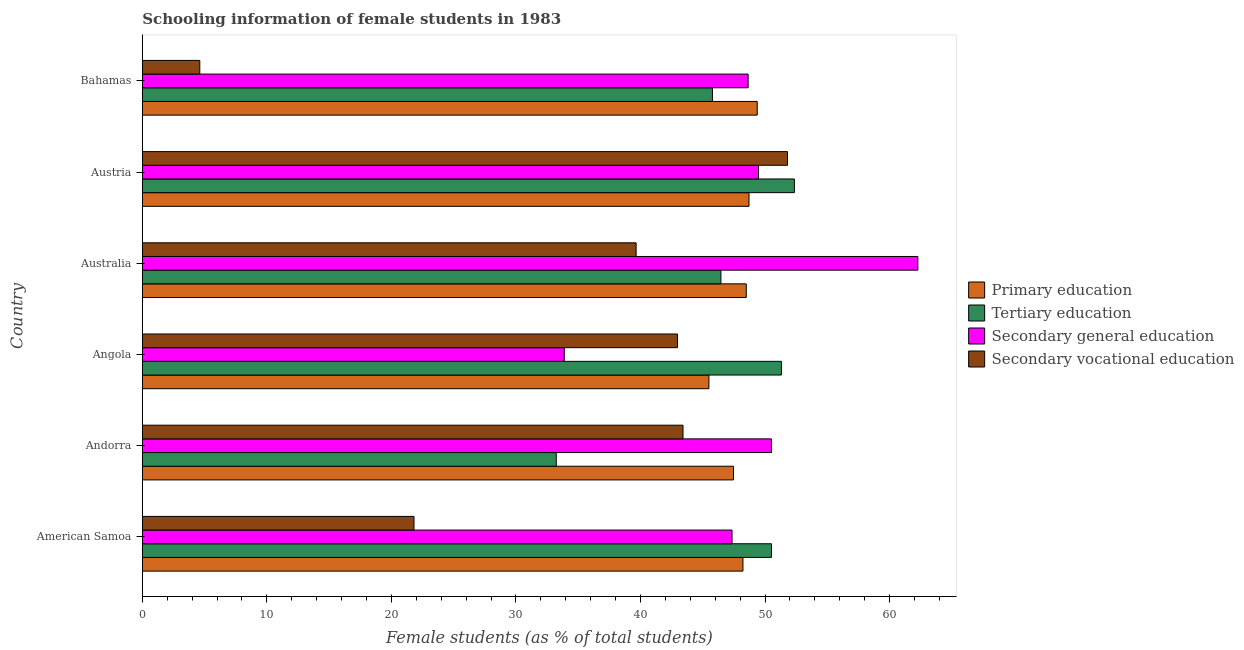How many groups of bars are there?
Give a very brief answer. 6. Are the number of bars on each tick of the Y-axis equal?
Provide a succinct answer. Yes. How many bars are there on the 4th tick from the top?
Keep it short and to the point. 4. What is the label of the 1st group of bars from the top?
Your response must be concise. Bahamas. What is the percentage of female students in tertiary education in American Samoa?
Give a very brief answer. 50.52. Across all countries, what is the maximum percentage of female students in secondary vocational education?
Your response must be concise. 51.8. Across all countries, what is the minimum percentage of female students in primary education?
Offer a terse response. 45.49. In which country was the percentage of female students in secondary education maximum?
Make the answer very short. Australia. In which country was the percentage of female students in secondary education minimum?
Your response must be concise. Angola. What is the total percentage of female students in secondary education in the graph?
Give a very brief answer. 292.13. What is the difference between the percentage of female students in tertiary education in Australia and that in Bahamas?
Offer a terse response. 0.68. What is the difference between the percentage of female students in tertiary education in Angola and the percentage of female students in primary education in Bahamas?
Your answer should be very brief. 1.94. What is the average percentage of female students in tertiary education per country?
Offer a very short reply. 46.61. What is the difference between the percentage of female students in tertiary education and percentage of female students in secondary vocational education in Bahamas?
Your response must be concise. 41.16. Is the percentage of female students in secondary education in Andorra less than that in Bahamas?
Your response must be concise. No. Is the difference between the percentage of female students in secondary vocational education in Angola and Austria greater than the difference between the percentage of female students in tertiary education in Angola and Austria?
Give a very brief answer. No. What is the difference between the highest and the second highest percentage of female students in primary education?
Offer a terse response. 0.66. What is the difference between the highest and the lowest percentage of female students in tertiary education?
Provide a short and direct response. 19.12. In how many countries, is the percentage of female students in primary education greater than the average percentage of female students in primary education taken over all countries?
Keep it short and to the point. 4. Is the sum of the percentage of female students in secondary vocational education in American Samoa and Bahamas greater than the maximum percentage of female students in primary education across all countries?
Give a very brief answer. No. What does the 1st bar from the top in Bahamas represents?
Give a very brief answer. Secondary vocational education. What does the 3rd bar from the bottom in American Samoa represents?
Your response must be concise. Secondary general education. Is it the case that in every country, the sum of the percentage of female students in primary education and percentage of female students in tertiary education is greater than the percentage of female students in secondary education?
Give a very brief answer. Yes. Are all the bars in the graph horizontal?
Your answer should be compact. Yes. What is the difference between two consecutive major ticks on the X-axis?
Your answer should be compact. 10. Are the values on the major ticks of X-axis written in scientific E-notation?
Offer a terse response. No. Does the graph contain grids?
Provide a short and direct response. No. How many legend labels are there?
Give a very brief answer. 4. What is the title of the graph?
Your answer should be compact. Schooling information of female students in 1983. What is the label or title of the X-axis?
Offer a very short reply. Female students (as % of total students). What is the label or title of the Y-axis?
Provide a short and direct response. Country. What is the Female students (as % of total students) in Primary education in American Samoa?
Provide a short and direct response. 48.22. What is the Female students (as % of total students) of Tertiary education in American Samoa?
Your response must be concise. 50.52. What is the Female students (as % of total students) in Secondary general education in American Samoa?
Give a very brief answer. 47.35. What is the Female students (as % of total students) in Secondary vocational education in American Samoa?
Offer a very short reply. 21.81. What is the Female students (as % of total students) of Primary education in Andorra?
Provide a short and direct response. 47.47. What is the Female students (as % of total students) of Tertiary education in Andorra?
Provide a short and direct response. 33.23. What is the Female students (as % of total students) in Secondary general education in Andorra?
Provide a succinct answer. 50.52. What is the Female students (as % of total students) of Secondary vocational education in Andorra?
Keep it short and to the point. 43.41. What is the Female students (as % of total students) in Primary education in Angola?
Provide a short and direct response. 45.49. What is the Female students (as % of total students) of Tertiary education in Angola?
Your answer should be compact. 51.32. What is the Female students (as % of total students) in Secondary general education in Angola?
Your response must be concise. 33.88. What is the Female students (as % of total students) of Secondary vocational education in Angola?
Your response must be concise. 42.97. What is the Female students (as % of total students) of Primary education in Australia?
Provide a succinct answer. 48.49. What is the Female students (as % of total students) of Tertiary education in Australia?
Your answer should be compact. 46.46. What is the Female students (as % of total students) of Secondary general education in Australia?
Provide a short and direct response. 62.27. What is the Female students (as % of total students) of Secondary vocational education in Australia?
Make the answer very short. 39.65. What is the Female students (as % of total students) of Primary education in Austria?
Your response must be concise. 48.71. What is the Female students (as % of total students) in Tertiary education in Austria?
Give a very brief answer. 52.36. What is the Female students (as % of total students) in Secondary general education in Austria?
Provide a short and direct response. 49.48. What is the Female students (as % of total students) of Secondary vocational education in Austria?
Your answer should be very brief. 51.8. What is the Female students (as % of total students) of Primary education in Bahamas?
Make the answer very short. 49.37. What is the Female students (as % of total students) of Tertiary education in Bahamas?
Make the answer very short. 45.78. What is the Female students (as % of total students) in Secondary general education in Bahamas?
Ensure brevity in your answer.  48.64. What is the Female students (as % of total students) of Secondary vocational education in Bahamas?
Make the answer very short. 4.61. Across all countries, what is the maximum Female students (as % of total students) in Primary education?
Your answer should be very brief. 49.37. Across all countries, what is the maximum Female students (as % of total students) of Tertiary education?
Provide a succinct answer. 52.36. Across all countries, what is the maximum Female students (as % of total students) of Secondary general education?
Your response must be concise. 62.27. Across all countries, what is the maximum Female students (as % of total students) of Secondary vocational education?
Offer a very short reply. 51.8. Across all countries, what is the minimum Female students (as % of total students) in Primary education?
Your answer should be compact. 45.49. Across all countries, what is the minimum Female students (as % of total students) in Tertiary education?
Make the answer very short. 33.23. Across all countries, what is the minimum Female students (as % of total students) of Secondary general education?
Your answer should be compact. 33.88. Across all countries, what is the minimum Female students (as % of total students) in Secondary vocational education?
Your answer should be very brief. 4.61. What is the total Female students (as % of total students) of Primary education in the graph?
Your response must be concise. 287.76. What is the total Female students (as % of total students) of Tertiary education in the graph?
Keep it short and to the point. 279.66. What is the total Female students (as % of total students) in Secondary general education in the graph?
Make the answer very short. 292.13. What is the total Female students (as % of total students) in Secondary vocational education in the graph?
Ensure brevity in your answer.  204.26. What is the difference between the Female students (as % of total students) of Primary education in American Samoa and that in Andorra?
Your answer should be very brief. 0.76. What is the difference between the Female students (as % of total students) of Tertiary education in American Samoa and that in Andorra?
Your answer should be compact. 17.28. What is the difference between the Female students (as % of total students) in Secondary general education in American Samoa and that in Andorra?
Keep it short and to the point. -3.17. What is the difference between the Female students (as % of total students) of Secondary vocational education in American Samoa and that in Andorra?
Give a very brief answer. -21.6. What is the difference between the Female students (as % of total students) in Primary education in American Samoa and that in Angola?
Offer a very short reply. 2.73. What is the difference between the Female students (as % of total students) in Tertiary education in American Samoa and that in Angola?
Give a very brief answer. -0.8. What is the difference between the Female students (as % of total students) of Secondary general education in American Samoa and that in Angola?
Make the answer very short. 13.47. What is the difference between the Female students (as % of total students) of Secondary vocational education in American Samoa and that in Angola?
Your answer should be very brief. -21.16. What is the difference between the Female students (as % of total students) in Primary education in American Samoa and that in Australia?
Your answer should be very brief. -0.27. What is the difference between the Female students (as % of total students) of Tertiary education in American Samoa and that in Australia?
Offer a very short reply. 4.06. What is the difference between the Female students (as % of total students) in Secondary general education in American Samoa and that in Australia?
Your response must be concise. -14.92. What is the difference between the Female students (as % of total students) of Secondary vocational education in American Samoa and that in Australia?
Offer a terse response. -17.83. What is the difference between the Female students (as % of total students) in Primary education in American Samoa and that in Austria?
Offer a terse response. -0.49. What is the difference between the Female students (as % of total students) of Tertiary education in American Samoa and that in Austria?
Give a very brief answer. -1.84. What is the difference between the Female students (as % of total students) of Secondary general education in American Samoa and that in Austria?
Give a very brief answer. -2.13. What is the difference between the Female students (as % of total students) in Secondary vocational education in American Samoa and that in Austria?
Make the answer very short. -29.99. What is the difference between the Female students (as % of total students) of Primary education in American Samoa and that in Bahamas?
Your response must be concise. -1.15. What is the difference between the Female students (as % of total students) of Tertiary education in American Samoa and that in Bahamas?
Your response must be concise. 4.74. What is the difference between the Female students (as % of total students) in Secondary general education in American Samoa and that in Bahamas?
Provide a succinct answer. -1.29. What is the difference between the Female students (as % of total students) in Secondary vocational education in American Samoa and that in Bahamas?
Provide a succinct answer. 17.2. What is the difference between the Female students (as % of total students) in Primary education in Andorra and that in Angola?
Give a very brief answer. 1.97. What is the difference between the Female students (as % of total students) in Tertiary education in Andorra and that in Angola?
Provide a short and direct response. -18.08. What is the difference between the Female students (as % of total students) in Secondary general education in Andorra and that in Angola?
Provide a succinct answer. 16.64. What is the difference between the Female students (as % of total students) in Secondary vocational education in Andorra and that in Angola?
Offer a terse response. 0.44. What is the difference between the Female students (as % of total students) of Primary education in Andorra and that in Australia?
Provide a short and direct response. -1.03. What is the difference between the Female students (as % of total students) of Tertiary education in Andorra and that in Australia?
Offer a very short reply. -13.22. What is the difference between the Female students (as % of total students) in Secondary general education in Andorra and that in Australia?
Provide a short and direct response. -11.75. What is the difference between the Female students (as % of total students) in Secondary vocational education in Andorra and that in Australia?
Make the answer very short. 3.77. What is the difference between the Female students (as % of total students) of Primary education in Andorra and that in Austria?
Provide a short and direct response. -1.25. What is the difference between the Female students (as % of total students) of Tertiary education in Andorra and that in Austria?
Give a very brief answer. -19.12. What is the difference between the Female students (as % of total students) in Secondary vocational education in Andorra and that in Austria?
Make the answer very short. -8.39. What is the difference between the Female students (as % of total students) in Primary education in Andorra and that in Bahamas?
Ensure brevity in your answer.  -1.91. What is the difference between the Female students (as % of total students) of Tertiary education in Andorra and that in Bahamas?
Ensure brevity in your answer.  -12.54. What is the difference between the Female students (as % of total students) of Secondary general education in Andorra and that in Bahamas?
Offer a very short reply. 1.87. What is the difference between the Female students (as % of total students) of Secondary vocational education in Andorra and that in Bahamas?
Your response must be concise. 38.8. What is the difference between the Female students (as % of total students) in Primary education in Angola and that in Australia?
Your response must be concise. -3. What is the difference between the Female students (as % of total students) of Tertiary education in Angola and that in Australia?
Your answer should be compact. 4.86. What is the difference between the Female students (as % of total students) of Secondary general education in Angola and that in Australia?
Your answer should be compact. -28.39. What is the difference between the Female students (as % of total students) in Secondary vocational education in Angola and that in Australia?
Offer a terse response. 3.32. What is the difference between the Female students (as % of total students) of Primary education in Angola and that in Austria?
Your answer should be very brief. -3.22. What is the difference between the Female students (as % of total students) of Tertiary education in Angola and that in Austria?
Your answer should be very brief. -1.04. What is the difference between the Female students (as % of total students) in Secondary general education in Angola and that in Austria?
Provide a succinct answer. -15.6. What is the difference between the Female students (as % of total students) in Secondary vocational education in Angola and that in Austria?
Make the answer very short. -8.83. What is the difference between the Female students (as % of total students) of Primary education in Angola and that in Bahamas?
Provide a short and direct response. -3.88. What is the difference between the Female students (as % of total students) of Tertiary education in Angola and that in Bahamas?
Your answer should be compact. 5.54. What is the difference between the Female students (as % of total students) in Secondary general education in Angola and that in Bahamas?
Your answer should be very brief. -14.76. What is the difference between the Female students (as % of total students) of Secondary vocational education in Angola and that in Bahamas?
Ensure brevity in your answer.  38.36. What is the difference between the Female students (as % of total students) in Primary education in Australia and that in Austria?
Offer a terse response. -0.22. What is the difference between the Female students (as % of total students) of Tertiary education in Australia and that in Austria?
Offer a terse response. -5.9. What is the difference between the Female students (as % of total students) of Secondary general education in Australia and that in Austria?
Give a very brief answer. 12.79. What is the difference between the Female students (as % of total students) of Secondary vocational education in Australia and that in Austria?
Give a very brief answer. -12.15. What is the difference between the Female students (as % of total students) of Primary education in Australia and that in Bahamas?
Give a very brief answer. -0.88. What is the difference between the Female students (as % of total students) in Tertiary education in Australia and that in Bahamas?
Your response must be concise. 0.68. What is the difference between the Female students (as % of total students) in Secondary general education in Australia and that in Bahamas?
Your answer should be very brief. 13.63. What is the difference between the Female students (as % of total students) of Secondary vocational education in Australia and that in Bahamas?
Make the answer very short. 35.03. What is the difference between the Female students (as % of total students) of Primary education in Austria and that in Bahamas?
Your response must be concise. -0.66. What is the difference between the Female students (as % of total students) in Tertiary education in Austria and that in Bahamas?
Your answer should be very brief. 6.58. What is the difference between the Female students (as % of total students) of Secondary general education in Austria and that in Bahamas?
Give a very brief answer. 0.83. What is the difference between the Female students (as % of total students) of Secondary vocational education in Austria and that in Bahamas?
Keep it short and to the point. 47.19. What is the difference between the Female students (as % of total students) in Primary education in American Samoa and the Female students (as % of total students) in Tertiary education in Andorra?
Offer a terse response. 14.99. What is the difference between the Female students (as % of total students) of Primary education in American Samoa and the Female students (as % of total students) of Secondary general education in Andorra?
Ensure brevity in your answer.  -2.29. What is the difference between the Female students (as % of total students) of Primary education in American Samoa and the Female students (as % of total students) of Secondary vocational education in Andorra?
Your response must be concise. 4.81. What is the difference between the Female students (as % of total students) in Tertiary education in American Samoa and the Female students (as % of total students) in Secondary general education in Andorra?
Provide a short and direct response. 0. What is the difference between the Female students (as % of total students) of Tertiary education in American Samoa and the Female students (as % of total students) of Secondary vocational education in Andorra?
Keep it short and to the point. 7.1. What is the difference between the Female students (as % of total students) in Secondary general education in American Samoa and the Female students (as % of total students) in Secondary vocational education in Andorra?
Make the answer very short. 3.94. What is the difference between the Female students (as % of total students) of Primary education in American Samoa and the Female students (as % of total students) of Tertiary education in Angola?
Provide a short and direct response. -3.09. What is the difference between the Female students (as % of total students) of Primary education in American Samoa and the Female students (as % of total students) of Secondary general education in Angola?
Offer a very short reply. 14.34. What is the difference between the Female students (as % of total students) in Primary education in American Samoa and the Female students (as % of total students) in Secondary vocational education in Angola?
Your answer should be very brief. 5.25. What is the difference between the Female students (as % of total students) of Tertiary education in American Samoa and the Female students (as % of total students) of Secondary general education in Angola?
Offer a very short reply. 16.64. What is the difference between the Female students (as % of total students) of Tertiary education in American Samoa and the Female students (as % of total students) of Secondary vocational education in Angola?
Make the answer very short. 7.55. What is the difference between the Female students (as % of total students) of Secondary general education in American Samoa and the Female students (as % of total students) of Secondary vocational education in Angola?
Keep it short and to the point. 4.38. What is the difference between the Female students (as % of total students) in Primary education in American Samoa and the Female students (as % of total students) in Tertiary education in Australia?
Offer a very short reply. 1.77. What is the difference between the Female students (as % of total students) in Primary education in American Samoa and the Female students (as % of total students) in Secondary general education in Australia?
Offer a terse response. -14.05. What is the difference between the Female students (as % of total students) of Primary education in American Samoa and the Female students (as % of total students) of Secondary vocational education in Australia?
Keep it short and to the point. 8.58. What is the difference between the Female students (as % of total students) in Tertiary education in American Samoa and the Female students (as % of total students) in Secondary general education in Australia?
Ensure brevity in your answer.  -11.75. What is the difference between the Female students (as % of total students) in Tertiary education in American Samoa and the Female students (as % of total students) in Secondary vocational education in Australia?
Your response must be concise. 10.87. What is the difference between the Female students (as % of total students) of Secondary general education in American Samoa and the Female students (as % of total students) of Secondary vocational education in Australia?
Your answer should be very brief. 7.7. What is the difference between the Female students (as % of total students) in Primary education in American Samoa and the Female students (as % of total students) in Tertiary education in Austria?
Ensure brevity in your answer.  -4.13. What is the difference between the Female students (as % of total students) in Primary education in American Samoa and the Female students (as % of total students) in Secondary general education in Austria?
Keep it short and to the point. -1.25. What is the difference between the Female students (as % of total students) of Primary education in American Samoa and the Female students (as % of total students) of Secondary vocational education in Austria?
Provide a succinct answer. -3.58. What is the difference between the Female students (as % of total students) in Tertiary education in American Samoa and the Female students (as % of total students) in Secondary general education in Austria?
Provide a succinct answer. 1.04. What is the difference between the Female students (as % of total students) in Tertiary education in American Samoa and the Female students (as % of total students) in Secondary vocational education in Austria?
Your answer should be very brief. -1.29. What is the difference between the Female students (as % of total students) in Secondary general education in American Samoa and the Female students (as % of total students) in Secondary vocational education in Austria?
Your answer should be compact. -4.45. What is the difference between the Female students (as % of total students) in Primary education in American Samoa and the Female students (as % of total students) in Tertiary education in Bahamas?
Ensure brevity in your answer.  2.45. What is the difference between the Female students (as % of total students) of Primary education in American Samoa and the Female students (as % of total students) of Secondary general education in Bahamas?
Offer a terse response. -0.42. What is the difference between the Female students (as % of total students) in Primary education in American Samoa and the Female students (as % of total students) in Secondary vocational education in Bahamas?
Provide a short and direct response. 43.61. What is the difference between the Female students (as % of total students) in Tertiary education in American Samoa and the Female students (as % of total students) in Secondary general education in Bahamas?
Provide a succinct answer. 1.87. What is the difference between the Female students (as % of total students) of Tertiary education in American Samoa and the Female students (as % of total students) of Secondary vocational education in Bahamas?
Give a very brief answer. 45.9. What is the difference between the Female students (as % of total students) in Secondary general education in American Samoa and the Female students (as % of total students) in Secondary vocational education in Bahamas?
Your answer should be compact. 42.74. What is the difference between the Female students (as % of total students) of Primary education in Andorra and the Female students (as % of total students) of Tertiary education in Angola?
Your answer should be very brief. -3.85. What is the difference between the Female students (as % of total students) in Primary education in Andorra and the Female students (as % of total students) in Secondary general education in Angola?
Provide a succinct answer. 13.59. What is the difference between the Female students (as % of total students) of Primary education in Andorra and the Female students (as % of total students) of Secondary vocational education in Angola?
Provide a short and direct response. 4.5. What is the difference between the Female students (as % of total students) in Tertiary education in Andorra and the Female students (as % of total students) in Secondary general education in Angola?
Give a very brief answer. -0.65. What is the difference between the Female students (as % of total students) of Tertiary education in Andorra and the Female students (as % of total students) of Secondary vocational education in Angola?
Ensure brevity in your answer.  -9.74. What is the difference between the Female students (as % of total students) of Secondary general education in Andorra and the Female students (as % of total students) of Secondary vocational education in Angola?
Make the answer very short. 7.55. What is the difference between the Female students (as % of total students) in Primary education in Andorra and the Female students (as % of total students) in Tertiary education in Australia?
Provide a short and direct response. 1.01. What is the difference between the Female students (as % of total students) of Primary education in Andorra and the Female students (as % of total students) of Secondary general education in Australia?
Provide a succinct answer. -14.8. What is the difference between the Female students (as % of total students) in Primary education in Andorra and the Female students (as % of total students) in Secondary vocational education in Australia?
Ensure brevity in your answer.  7.82. What is the difference between the Female students (as % of total students) of Tertiary education in Andorra and the Female students (as % of total students) of Secondary general education in Australia?
Ensure brevity in your answer.  -29.04. What is the difference between the Female students (as % of total students) in Tertiary education in Andorra and the Female students (as % of total students) in Secondary vocational education in Australia?
Keep it short and to the point. -6.41. What is the difference between the Female students (as % of total students) of Secondary general education in Andorra and the Female students (as % of total students) of Secondary vocational education in Australia?
Your answer should be compact. 10.87. What is the difference between the Female students (as % of total students) in Primary education in Andorra and the Female students (as % of total students) in Tertiary education in Austria?
Provide a short and direct response. -4.89. What is the difference between the Female students (as % of total students) of Primary education in Andorra and the Female students (as % of total students) of Secondary general education in Austria?
Make the answer very short. -2.01. What is the difference between the Female students (as % of total students) of Primary education in Andorra and the Female students (as % of total students) of Secondary vocational education in Austria?
Ensure brevity in your answer.  -4.34. What is the difference between the Female students (as % of total students) of Tertiary education in Andorra and the Female students (as % of total students) of Secondary general education in Austria?
Your answer should be very brief. -16.24. What is the difference between the Female students (as % of total students) of Tertiary education in Andorra and the Female students (as % of total students) of Secondary vocational education in Austria?
Provide a succinct answer. -18.57. What is the difference between the Female students (as % of total students) in Secondary general education in Andorra and the Female students (as % of total students) in Secondary vocational education in Austria?
Provide a short and direct response. -1.29. What is the difference between the Female students (as % of total students) of Primary education in Andorra and the Female students (as % of total students) of Tertiary education in Bahamas?
Offer a very short reply. 1.69. What is the difference between the Female students (as % of total students) in Primary education in Andorra and the Female students (as % of total students) in Secondary general education in Bahamas?
Keep it short and to the point. -1.18. What is the difference between the Female students (as % of total students) of Primary education in Andorra and the Female students (as % of total students) of Secondary vocational education in Bahamas?
Provide a short and direct response. 42.85. What is the difference between the Female students (as % of total students) of Tertiary education in Andorra and the Female students (as % of total students) of Secondary general education in Bahamas?
Provide a succinct answer. -15.41. What is the difference between the Female students (as % of total students) of Tertiary education in Andorra and the Female students (as % of total students) of Secondary vocational education in Bahamas?
Your response must be concise. 28.62. What is the difference between the Female students (as % of total students) of Secondary general education in Andorra and the Female students (as % of total students) of Secondary vocational education in Bahamas?
Ensure brevity in your answer.  45.9. What is the difference between the Female students (as % of total students) of Primary education in Angola and the Female students (as % of total students) of Tertiary education in Australia?
Offer a terse response. -0.96. What is the difference between the Female students (as % of total students) of Primary education in Angola and the Female students (as % of total students) of Secondary general education in Australia?
Offer a terse response. -16.78. What is the difference between the Female students (as % of total students) in Primary education in Angola and the Female students (as % of total students) in Secondary vocational education in Australia?
Make the answer very short. 5.85. What is the difference between the Female students (as % of total students) in Tertiary education in Angola and the Female students (as % of total students) in Secondary general education in Australia?
Make the answer very short. -10.95. What is the difference between the Female students (as % of total students) of Tertiary education in Angola and the Female students (as % of total students) of Secondary vocational education in Australia?
Your answer should be compact. 11.67. What is the difference between the Female students (as % of total students) of Secondary general education in Angola and the Female students (as % of total students) of Secondary vocational education in Australia?
Make the answer very short. -5.77. What is the difference between the Female students (as % of total students) of Primary education in Angola and the Female students (as % of total students) of Tertiary education in Austria?
Your answer should be very brief. -6.86. What is the difference between the Female students (as % of total students) in Primary education in Angola and the Female students (as % of total students) in Secondary general education in Austria?
Ensure brevity in your answer.  -3.98. What is the difference between the Female students (as % of total students) of Primary education in Angola and the Female students (as % of total students) of Secondary vocational education in Austria?
Your response must be concise. -6.31. What is the difference between the Female students (as % of total students) in Tertiary education in Angola and the Female students (as % of total students) in Secondary general education in Austria?
Your answer should be compact. 1.84. What is the difference between the Female students (as % of total students) in Tertiary education in Angola and the Female students (as % of total students) in Secondary vocational education in Austria?
Provide a short and direct response. -0.49. What is the difference between the Female students (as % of total students) of Secondary general education in Angola and the Female students (as % of total students) of Secondary vocational education in Austria?
Give a very brief answer. -17.92. What is the difference between the Female students (as % of total students) of Primary education in Angola and the Female students (as % of total students) of Tertiary education in Bahamas?
Keep it short and to the point. -0.28. What is the difference between the Female students (as % of total students) of Primary education in Angola and the Female students (as % of total students) of Secondary general education in Bahamas?
Your response must be concise. -3.15. What is the difference between the Female students (as % of total students) in Primary education in Angola and the Female students (as % of total students) in Secondary vocational education in Bahamas?
Your answer should be compact. 40.88. What is the difference between the Female students (as % of total students) of Tertiary education in Angola and the Female students (as % of total students) of Secondary general education in Bahamas?
Provide a succinct answer. 2.67. What is the difference between the Female students (as % of total students) of Tertiary education in Angola and the Female students (as % of total students) of Secondary vocational education in Bahamas?
Your answer should be very brief. 46.7. What is the difference between the Female students (as % of total students) of Secondary general education in Angola and the Female students (as % of total students) of Secondary vocational education in Bahamas?
Your answer should be compact. 29.27. What is the difference between the Female students (as % of total students) in Primary education in Australia and the Female students (as % of total students) in Tertiary education in Austria?
Give a very brief answer. -3.86. What is the difference between the Female students (as % of total students) in Primary education in Australia and the Female students (as % of total students) in Secondary general education in Austria?
Make the answer very short. -0.98. What is the difference between the Female students (as % of total students) of Primary education in Australia and the Female students (as % of total students) of Secondary vocational education in Austria?
Your answer should be compact. -3.31. What is the difference between the Female students (as % of total students) in Tertiary education in Australia and the Female students (as % of total students) in Secondary general education in Austria?
Provide a succinct answer. -3.02. What is the difference between the Female students (as % of total students) of Tertiary education in Australia and the Female students (as % of total students) of Secondary vocational education in Austria?
Make the answer very short. -5.35. What is the difference between the Female students (as % of total students) of Secondary general education in Australia and the Female students (as % of total students) of Secondary vocational education in Austria?
Make the answer very short. 10.47. What is the difference between the Female students (as % of total students) in Primary education in Australia and the Female students (as % of total students) in Tertiary education in Bahamas?
Your response must be concise. 2.72. What is the difference between the Female students (as % of total students) in Primary education in Australia and the Female students (as % of total students) in Secondary general education in Bahamas?
Your answer should be compact. -0.15. What is the difference between the Female students (as % of total students) of Primary education in Australia and the Female students (as % of total students) of Secondary vocational education in Bahamas?
Make the answer very short. 43.88. What is the difference between the Female students (as % of total students) in Tertiary education in Australia and the Female students (as % of total students) in Secondary general education in Bahamas?
Provide a succinct answer. -2.19. What is the difference between the Female students (as % of total students) in Tertiary education in Australia and the Female students (as % of total students) in Secondary vocational education in Bahamas?
Provide a succinct answer. 41.84. What is the difference between the Female students (as % of total students) of Secondary general education in Australia and the Female students (as % of total students) of Secondary vocational education in Bahamas?
Provide a succinct answer. 57.66. What is the difference between the Female students (as % of total students) in Primary education in Austria and the Female students (as % of total students) in Tertiary education in Bahamas?
Keep it short and to the point. 2.94. What is the difference between the Female students (as % of total students) of Primary education in Austria and the Female students (as % of total students) of Secondary general education in Bahamas?
Your answer should be very brief. 0.07. What is the difference between the Female students (as % of total students) of Primary education in Austria and the Female students (as % of total students) of Secondary vocational education in Bahamas?
Your answer should be very brief. 44.1. What is the difference between the Female students (as % of total students) of Tertiary education in Austria and the Female students (as % of total students) of Secondary general education in Bahamas?
Offer a very short reply. 3.71. What is the difference between the Female students (as % of total students) in Tertiary education in Austria and the Female students (as % of total students) in Secondary vocational education in Bahamas?
Keep it short and to the point. 47.74. What is the difference between the Female students (as % of total students) of Secondary general education in Austria and the Female students (as % of total students) of Secondary vocational education in Bahamas?
Your answer should be compact. 44.86. What is the average Female students (as % of total students) of Primary education per country?
Keep it short and to the point. 47.96. What is the average Female students (as % of total students) in Tertiary education per country?
Make the answer very short. 46.61. What is the average Female students (as % of total students) of Secondary general education per country?
Ensure brevity in your answer.  48.69. What is the average Female students (as % of total students) in Secondary vocational education per country?
Ensure brevity in your answer.  34.04. What is the difference between the Female students (as % of total students) of Primary education and Female students (as % of total students) of Tertiary education in American Samoa?
Provide a succinct answer. -2.29. What is the difference between the Female students (as % of total students) in Primary education and Female students (as % of total students) in Secondary general education in American Samoa?
Give a very brief answer. 0.88. What is the difference between the Female students (as % of total students) in Primary education and Female students (as % of total students) in Secondary vocational education in American Samoa?
Give a very brief answer. 26.41. What is the difference between the Female students (as % of total students) of Tertiary education and Female students (as % of total students) of Secondary general education in American Samoa?
Make the answer very short. 3.17. What is the difference between the Female students (as % of total students) of Tertiary education and Female students (as % of total students) of Secondary vocational education in American Samoa?
Give a very brief answer. 28.7. What is the difference between the Female students (as % of total students) in Secondary general education and Female students (as % of total students) in Secondary vocational education in American Samoa?
Give a very brief answer. 25.54. What is the difference between the Female students (as % of total students) in Primary education and Female students (as % of total students) in Tertiary education in Andorra?
Give a very brief answer. 14.23. What is the difference between the Female students (as % of total students) in Primary education and Female students (as % of total students) in Secondary general education in Andorra?
Your answer should be very brief. -3.05. What is the difference between the Female students (as % of total students) in Primary education and Female students (as % of total students) in Secondary vocational education in Andorra?
Your answer should be very brief. 4.05. What is the difference between the Female students (as % of total students) of Tertiary education and Female students (as % of total students) of Secondary general education in Andorra?
Your answer should be compact. -17.28. What is the difference between the Female students (as % of total students) of Tertiary education and Female students (as % of total students) of Secondary vocational education in Andorra?
Provide a short and direct response. -10.18. What is the difference between the Female students (as % of total students) of Secondary general education and Female students (as % of total students) of Secondary vocational education in Andorra?
Keep it short and to the point. 7.1. What is the difference between the Female students (as % of total students) in Primary education and Female students (as % of total students) in Tertiary education in Angola?
Your response must be concise. -5.82. What is the difference between the Female students (as % of total students) in Primary education and Female students (as % of total students) in Secondary general education in Angola?
Ensure brevity in your answer.  11.61. What is the difference between the Female students (as % of total students) in Primary education and Female students (as % of total students) in Secondary vocational education in Angola?
Offer a very short reply. 2.52. What is the difference between the Female students (as % of total students) in Tertiary education and Female students (as % of total students) in Secondary general education in Angola?
Make the answer very short. 17.44. What is the difference between the Female students (as % of total students) of Tertiary education and Female students (as % of total students) of Secondary vocational education in Angola?
Offer a terse response. 8.35. What is the difference between the Female students (as % of total students) of Secondary general education and Female students (as % of total students) of Secondary vocational education in Angola?
Provide a succinct answer. -9.09. What is the difference between the Female students (as % of total students) in Primary education and Female students (as % of total students) in Tertiary education in Australia?
Provide a succinct answer. 2.04. What is the difference between the Female students (as % of total students) of Primary education and Female students (as % of total students) of Secondary general education in Australia?
Give a very brief answer. -13.78. What is the difference between the Female students (as % of total students) of Primary education and Female students (as % of total students) of Secondary vocational education in Australia?
Provide a succinct answer. 8.85. What is the difference between the Female students (as % of total students) in Tertiary education and Female students (as % of total students) in Secondary general education in Australia?
Provide a short and direct response. -15.81. What is the difference between the Female students (as % of total students) of Tertiary education and Female students (as % of total students) of Secondary vocational education in Australia?
Give a very brief answer. 6.81. What is the difference between the Female students (as % of total students) in Secondary general education and Female students (as % of total students) in Secondary vocational education in Australia?
Ensure brevity in your answer.  22.62. What is the difference between the Female students (as % of total students) of Primary education and Female students (as % of total students) of Tertiary education in Austria?
Your answer should be compact. -3.64. What is the difference between the Female students (as % of total students) of Primary education and Female students (as % of total students) of Secondary general education in Austria?
Provide a succinct answer. -0.77. What is the difference between the Female students (as % of total students) of Primary education and Female students (as % of total students) of Secondary vocational education in Austria?
Offer a very short reply. -3.09. What is the difference between the Female students (as % of total students) in Tertiary education and Female students (as % of total students) in Secondary general education in Austria?
Provide a succinct answer. 2.88. What is the difference between the Female students (as % of total students) in Tertiary education and Female students (as % of total students) in Secondary vocational education in Austria?
Offer a terse response. 0.55. What is the difference between the Female students (as % of total students) of Secondary general education and Female students (as % of total students) of Secondary vocational education in Austria?
Give a very brief answer. -2.33. What is the difference between the Female students (as % of total students) of Primary education and Female students (as % of total students) of Tertiary education in Bahamas?
Ensure brevity in your answer.  3.6. What is the difference between the Female students (as % of total students) of Primary education and Female students (as % of total students) of Secondary general education in Bahamas?
Provide a succinct answer. 0.73. What is the difference between the Female students (as % of total students) in Primary education and Female students (as % of total students) in Secondary vocational education in Bahamas?
Ensure brevity in your answer.  44.76. What is the difference between the Female students (as % of total students) in Tertiary education and Female students (as % of total students) in Secondary general education in Bahamas?
Keep it short and to the point. -2.87. What is the difference between the Female students (as % of total students) of Tertiary education and Female students (as % of total students) of Secondary vocational education in Bahamas?
Keep it short and to the point. 41.16. What is the difference between the Female students (as % of total students) of Secondary general education and Female students (as % of total students) of Secondary vocational education in Bahamas?
Your answer should be very brief. 44.03. What is the ratio of the Female students (as % of total students) of Primary education in American Samoa to that in Andorra?
Make the answer very short. 1.02. What is the ratio of the Female students (as % of total students) in Tertiary education in American Samoa to that in Andorra?
Your answer should be compact. 1.52. What is the ratio of the Female students (as % of total students) of Secondary general education in American Samoa to that in Andorra?
Keep it short and to the point. 0.94. What is the ratio of the Female students (as % of total students) of Secondary vocational education in American Samoa to that in Andorra?
Your response must be concise. 0.5. What is the ratio of the Female students (as % of total students) in Primary education in American Samoa to that in Angola?
Provide a short and direct response. 1.06. What is the ratio of the Female students (as % of total students) in Tertiary education in American Samoa to that in Angola?
Provide a succinct answer. 0.98. What is the ratio of the Female students (as % of total students) in Secondary general education in American Samoa to that in Angola?
Your response must be concise. 1.4. What is the ratio of the Female students (as % of total students) in Secondary vocational education in American Samoa to that in Angola?
Your answer should be compact. 0.51. What is the ratio of the Female students (as % of total students) of Primary education in American Samoa to that in Australia?
Give a very brief answer. 0.99. What is the ratio of the Female students (as % of total students) of Tertiary education in American Samoa to that in Australia?
Offer a very short reply. 1.09. What is the ratio of the Female students (as % of total students) in Secondary general education in American Samoa to that in Australia?
Provide a succinct answer. 0.76. What is the ratio of the Female students (as % of total students) of Secondary vocational education in American Samoa to that in Australia?
Your response must be concise. 0.55. What is the ratio of the Female students (as % of total students) of Tertiary education in American Samoa to that in Austria?
Offer a terse response. 0.96. What is the ratio of the Female students (as % of total students) in Secondary vocational education in American Samoa to that in Austria?
Provide a short and direct response. 0.42. What is the ratio of the Female students (as % of total students) in Primary education in American Samoa to that in Bahamas?
Offer a very short reply. 0.98. What is the ratio of the Female students (as % of total students) of Tertiary education in American Samoa to that in Bahamas?
Offer a very short reply. 1.1. What is the ratio of the Female students (as % of total students) in Secondary general education in American Samoa to that in Bahamas?
Give a very brief answer. 0.97. What is the ratio of the Female students (as % of total students) of Secondary vocational education in American Samoa to that in Bahamas?
Offer a terse response. 4.73. What is the ratio of the Female students (as % of total students) of Primary education in Andorra to that in Angola?
Your answer should be very brief. 1.04. What is the ratio of the Female students (as % of total students) of Tertiary education in Andorra to that in Angola?
Offer a very short reply. 0.65. What is the ratio of the Female students (as % of total students) in Secondary general education in Andorra to that in Angola?
Give a very brief answer. 1.49. What is the ratio of the Female students (as % of total students) in Secondary vocational education in Andorra to that in Angola?
Provide a succinct answer. 1.01. What is the ratio of the Female students (as % of total students) in Primary education in Andorra to that in Australia?
Provide a succinct answer. 0.98. What is the ratio of the Female students (as % of total students) of Tertiary education in Andorra to that in Australia?
Your response must be concise. 0.72. What is the ratio of the Female students (as % of total students) in Secondary general education in Andorra to that in Australia?
Keep it short and to the point. 0.81. What is the ratio of the Female students (as % of total students) in Secondary vocational education in Andorra to that in Australia?
Offer a terse response. 1.09. What is the ratio of the Female students (as % of total students) in Primary education in Andorra to that in Austria?
Offer a terse response. 0.97. What is the ratio of the Female students (as % of total students) in Tertiary education in Andorra to that in Austria?
Keep it short and to the point. 0.63. What is the ratio of the Female students (as % of total students) in Secondary general education in Andorra to that in Austria?
Your answer should be very brief. 1.02. What is the ratio of the Female students (as % of total students) in Secondary vocational education in Andorra to that in Austria?
Make the answer very short. 0.84. What is the ratio of the Female students (as % of total students) of Primary education in Andorra to that in Bahamas?
Offer a terse response. 0.96. What is the ratio of the Female students (as % of total students) in Tertiary education in Andorra to that in Bahamas?
Provide a short and direct response. 0.73. What is the ratio of the Female students (as % of total students) in Secondary general education in Andorra to that in Bahamas?
Make the answer very short. 1.04. What is the ratio of the Female students (as % of total students) of Secondary vocational education in Andorra to that in Bahamas?
Ensure brevity in your answer.  9.41. What is the ratio of the Female students (as % of total students) in Primary education in Angola to that in Australia?
Provide a short and direct response. 0.94. What is the ratio of the Female students (as % of total students) of Tertiary education in Angola to that in Australia?
Provide a short and direct response. 1.1. What is the ratio of the Female students (as % of total students) in Secondary general education in Angola to that in Australia?
Provide a succinct answer. 0.54. What is the ratio of the Female students (as % of total students) in Secondary vocational education in Angola to that in Australia?
Give a very brief answer. 1.08. What is the ratio of the Female students (as % of total students) of Primary education in Angola to that in Austria?
Provide a short and direct response. 0.93. What is the ratio of the Female students (as % of total students) of Tertiary education in Angola to that in Austria?
Provide a short and direct response. 0.98. What is the ratio of the Female students (as % of total students) in Secondary general education in Angola to that in Austria?
Give a very brief answer. 0.68. What is the ratio of the Female students (as % of total students) of Secondary vocational education in Angola to that in Austria?
Offer a terse response. 0.83. What is the ratio of the Female students (as % of total students) in Primary education in Angola to that in Bahamas?
Keep it short and to the point. 0.92. What is the ratio of the Female students (as % of total students) in Tertiary education in Angola to that in Bahamas?
Ensure brevity in your answer.  1.12. What is the ratio of the Female students (as % of total students) of Secondary general education in Angola to that in Bahamas?
Give a very brief answer. 0.7. What is the ratio of the Female students (as % of total students) in Secondary vocational education in Angola to that in Bahamas?
Offer a terse response. 9.31. What is the ratio of the Female students (as % of total students) in Tertiary education in Australia to that in Austria?
Give a very brief answer. 0.89. What is the ratio of the Female students (as % of total students) of Secondary general education in Australia to that in Austria?
Provide a short and direct response. 1.26. What is the ratio of the Female students (as % of total students) in Secondary vocational education in Australia to that in Austria?
Your response must be concise. 0.77. What is the ratio of the Female students (as % of total students) in Primary education in Australia to that in Bahamas?
Ensure brevity in your answer.  0.98. What is the ratio of the Female students (as % of total students) in Tertiary education in Australia to that in Bahamas?
Your answer should be compact. 1.01. What is the ratio of the Female students (as % of total students) of Secondary general education in Australia to that in Bahamas?
Your answer should be very brief. 1.28. What is the ratio of the Female students (as % of total students) in Secondary vocational education in Australia to that in Bahamas?
Your response must be concise. 8.59. What is the ratio of the Female students (as % of total students) of Primary education in Austria to that in Bahamas?
Provide a succinct answer. 0.99. What is the ratio of the Female students (as % of total students) of Tertiary education in Austria to that in Bahamas?
Your answer should be very brief. 1.14. What is the ratio of the Female students (as % of total students) in Secondary general education in Austria to that in Bahamas?
Your answer should be compact. 1.02. What is the ratio of the Female students (as % of total students) in Secondary vocational education in Austria to that in Bahamas?
Provide a succinct answer. 11.23. What is the difference between the highest and the second highest Female students (as % of total students) of Primary education?
Your response must be concise. 0.66. What is the difference between the highest and the second highest Female students (as % of total students) of Tertiary education?
Your response must be concise. 1.04. What is the difference between the highest and the second highest Female students (as % of total students) in Secondary general education?
Offer a terse response. 11.75. What is the difference between the highest and the second highest Female students (as % of total students) of Secondary vocational education?
Keep it short and to the point. 8.39. What is the difference between the highest and the lowest Female students (as % of total students) of Primary education?
Give a very brief answer. 3.88. What is the difference between the highest and the lowest Female students (as % of total students) of Tertiary education?
Ensure brevity in your answer.  19.12. What is the difference between the highest and the lowest Female students (as % of total students) of Secondary general education?
Your response must be concise. 28.39. What is the difference between the highest and the lowest Female students (as % of total students) in Secondary vocational education?
Offer a very short reply. 47.19. 